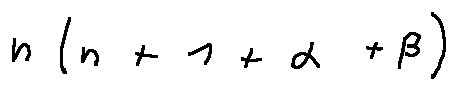<formula> <loc_0><loc_0><loc_500><loc_500>n ( n + 1 + \alpha + \beta )</formula> 